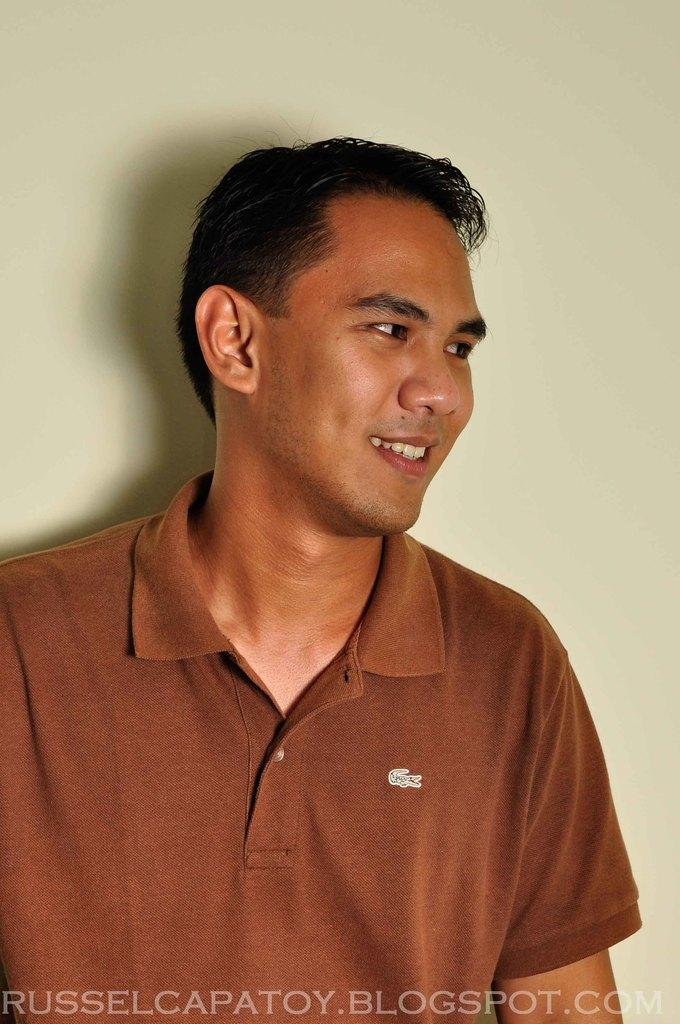Who is present in the image? There is a man in the image. What is the man's facial expression? The man is smiling. What can be seen behind the man? There is a wall visible behind the man. What is written or displayed at the bottom of the image? There is text at the bottom of the image. Can you see any feathers floating around the man in the image? No, there are no feathers visible in the image. Is there a porter assisting the man in the image? No, there is no porter present in the image. 